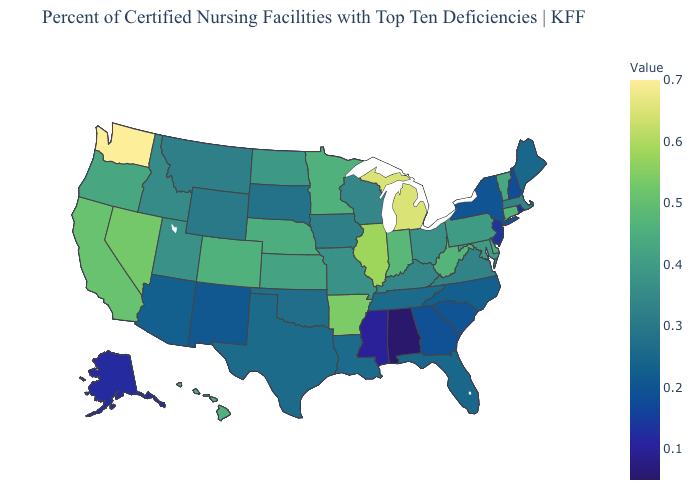Which states have the lowest value in the USA?
Concise answer only. Alabama. Does Montana have the highest value in the West?
Keep it brief. No. Among the states that border Kansas , which have the highest value?
Keep it brief. Colorado. Among the states that border Kansas , does Nebraska have the lowest value?
Keep it brief. No. Which states have the highest value in the USA?
Concise answer only. Washington. 